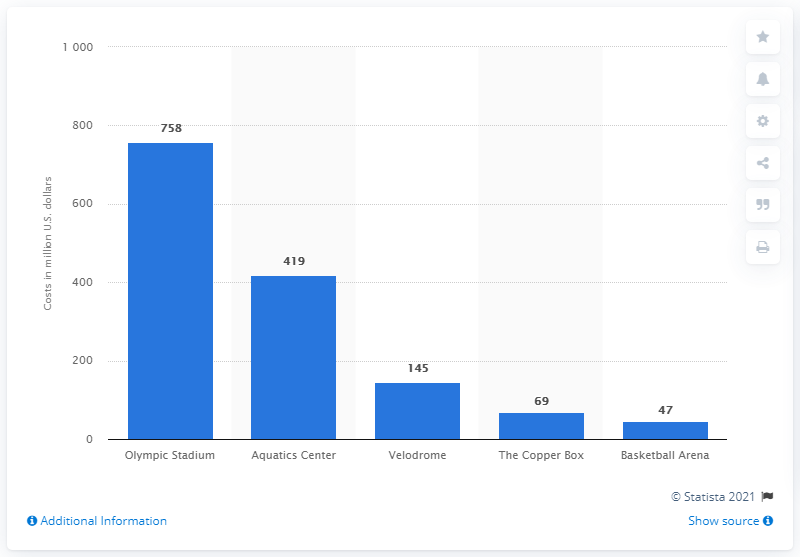Outline some significant characteristics in this image. The cost of the Velodrome in US dollars was approximately 145. 